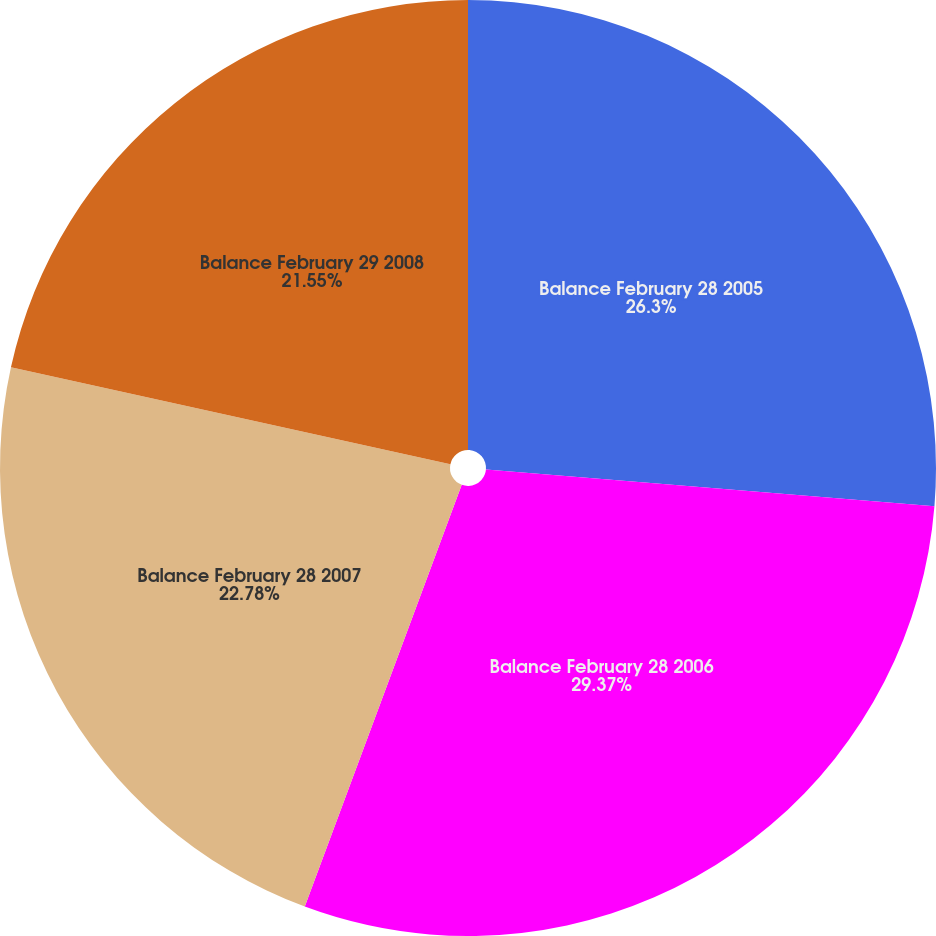Convert chart. <chart><loc_0><loc_0><loc_500><loc_500><pie_chart><fcel>Balance February 28 2005<fcel>Balance February 28 2006<fcel>Balance February 28 2007<fcel>Balance February 29 2008<nl><fcel>26.3%<fcel>29.37%<fcel>22.78%<fcel>21.55%<nl></chart> 